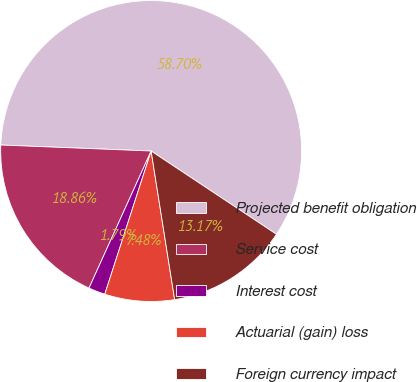Convert chart. <chart><loc_0><loc_0><loc_500><loc_500><pie_chart><fcel>Projected benefit obligation<fcel>Service cost<fcel>Interest cost<fcel>Actuarial (gain) loss<fcel>Foreign currency impact<nl><fcel>58.69%<fcel>18.86%<fcel>1.79%<fcel>7.48%<fcel>13.17%<nl></chart> 